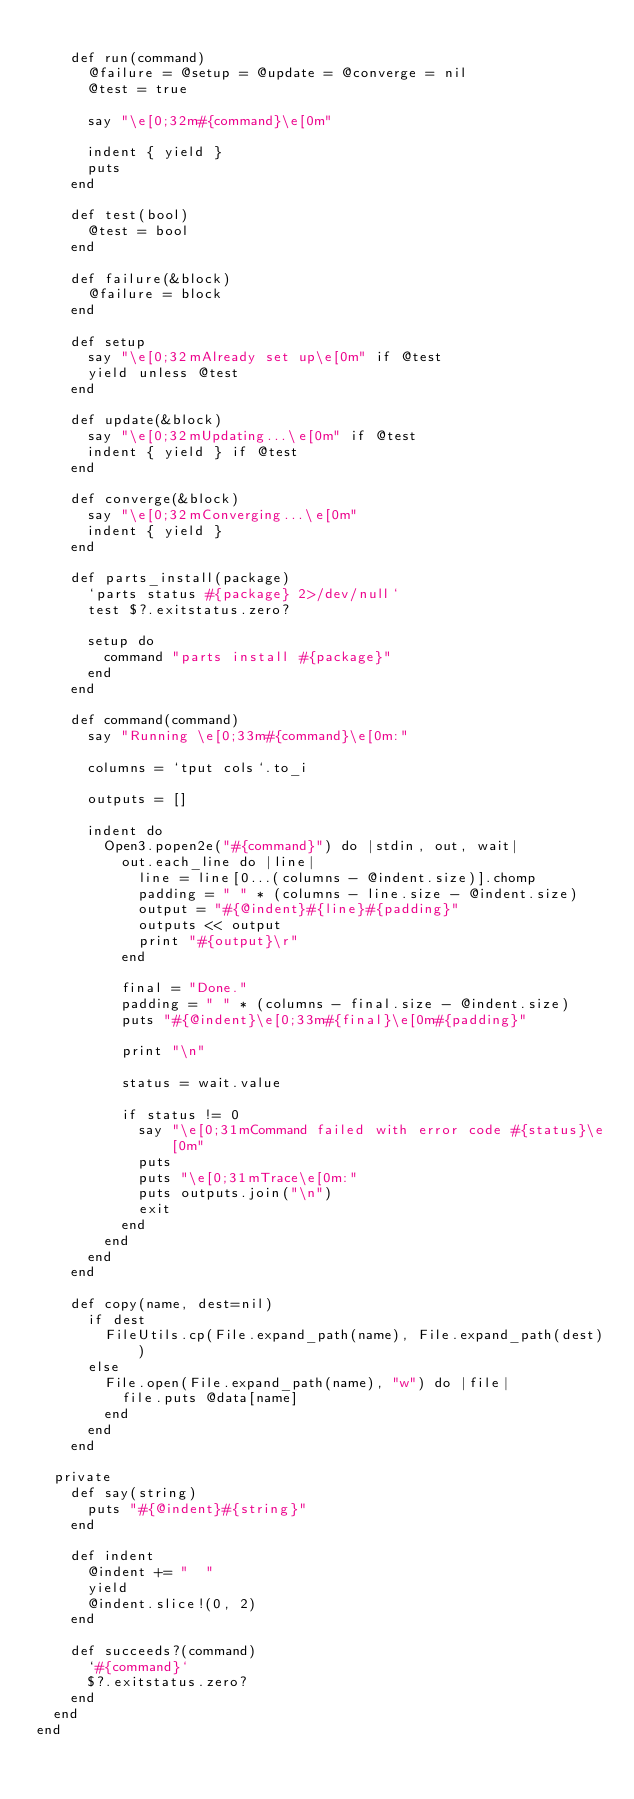<code> <loc_0><loc_0><loc_500><loc_500><_Ruby_>
    def run(command)
      @failure = @setup = @update = @converge = nil
      @test = true

      say "\e[0;32m#{command}\e[0m"

      indent { yield }
      puts
    end

    def test(bool)
      @test = bool
    end

    def failure(&block)
      @failure = block
    end

    def setup
      say "\e[0;32mAlready set up\e[0m" if @test
      yield unless @test
    end

    def update(&block)
      say "\e[0;32mUpdating...\e[0m" if @test
      indent { yield } if @test
    end

    def converge(&block)
      say "\e[0;32mConverging...\e[0m"
      indent { yield }
    end

    def parts_install(package)
      `parts status #{package} 2>/dev/null`
      test $?.exitstatus.zero?

      setup do
        command "parts install #{package}"
      end
    end

    def command(command)
      say "Running \e[0;33m#{command}\e[0m:"
      
      columns = `tput cols`.to_i

      outputs = []

      indent do
        Open3.popen2e("#{command}") do |stdin, out, wait|
          out.each_line do |line|
            line = line[0...(columns - @indent.size)].chomp
            padding = " " * (columns - line.size - @indent.size)
            output = "#{@indent}#{line}#{padding}"
            outputs << output
            print "#{output}\r"
          end

          final = "Done."
          padding = " " * (columns - final.size - @indent.size)
          puts "#{@indent}\e[0;33m#{final}\e[0m#{padding}"

          print "\n"

          status = wait.value

          if status != 0
            say "\e[0;31mCommand failed with error code #{status}\e[0m"
            puts
            puts "\e[0;31mTrace\e[0m:"
            puts outputs.join("\n")
            exit
          end
        end
      end
    end

    def copy(name, dest=nil)
      if dest
        FileUtils.cp(File.expand_path(name), File.expand_path(dest))
      else
        File.open(File.expand_path(name), "w") do |file|
          file.puts @data[name]
        end
      end
    end

  private
    def say(string)
      puts "#{@indent}#{string}"
    end

    def indent
      @indent += "  "
      yield
      @indent.slice!(0, 2)
    end

    def succeeds?(command)
      `#{command}`
      $?.exitstatus.zero?
    end
  end
end
</code> 